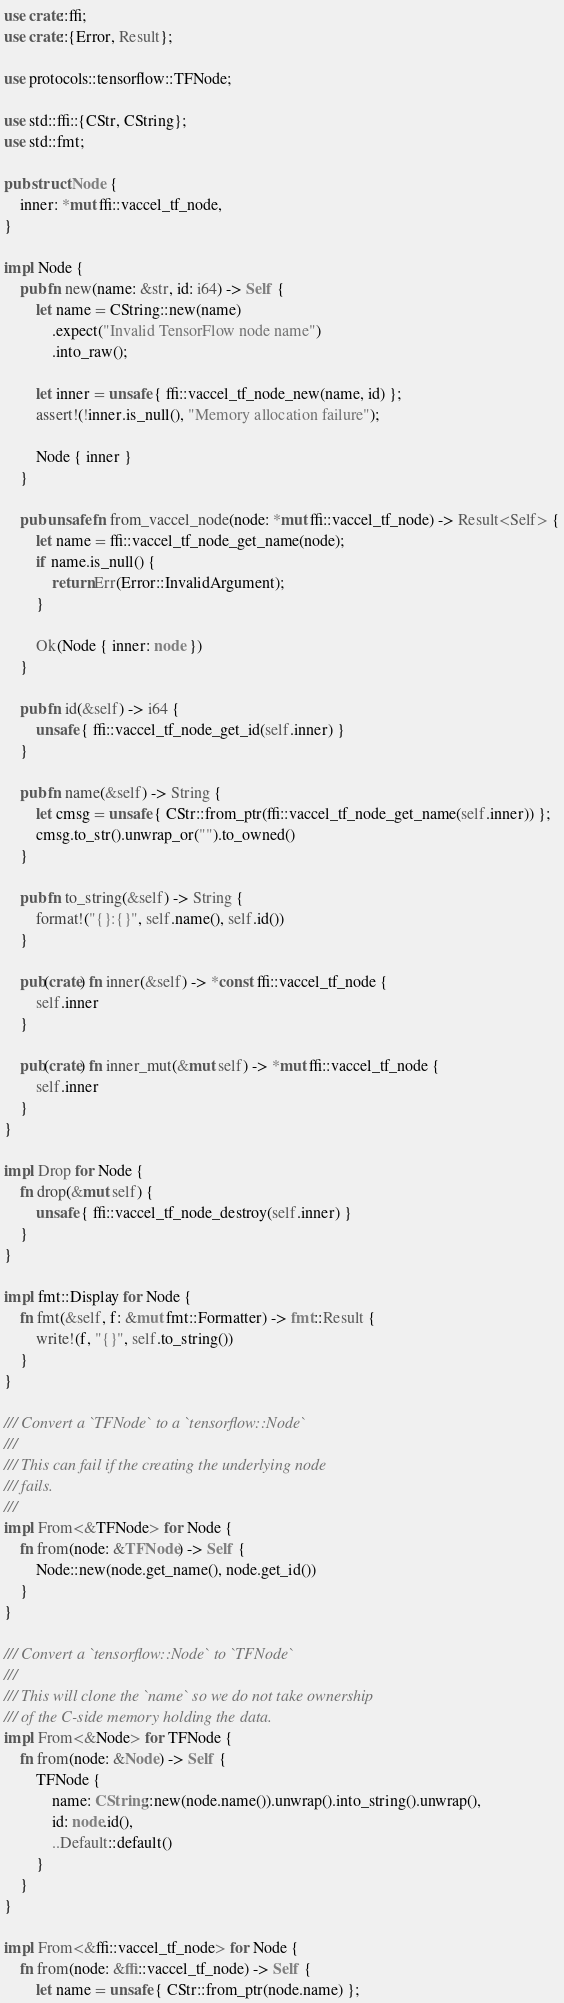<code> <loc_0><loc_0><loc_500><loc_500><_Rust_>use crate::ffi;
use crate::{Error, Result};

use protocols::tensorflow::TFNode;

use std::ffi::{CStr, CString};
use std::fmt;

pub struct Node {
    inner: *mut ffi::vaccel_tf_node,
}

impl Node {
    pub fn new(name: &str, id: i64) -> Self {
        let name = CString::new(name)
            .expect("Invalid TensorFlow node name")
            .into_raw();

        let inner = unsafe { ffi::vaccel_tf_node_new(name, id) };
        assert!(!inner.is_null(), "Memory allocation failure");

        Node { inner }
    }

    pub unsafe fn from_vaccel_node(node: *mut ffi::vaccel_tf_node) -> Result<Self> {
        let name = ffi::vaccel_tf_node_get_name(node);
        if name.is_null() {
            return Err(Error::InvalidArgument);
        }

        Ok(Node { inner: node })
    }

    pub fn id(&self) -> i64 {
        unsafe { ffi::vaccel_tf_node_get_id(self.inner) }
    }

    pub fn name(&self) -> String {
        let cmsg = unsafe { CStr::from_ptr(ffi::vaccel_tf_node_get_name(self.inner)) };
        cmsg.to_str().unwrap_or("").to_owned()
    }

    pub fn to_string(&self) -> String {
        format!("{}:{}", self.name(), self.id())
    }

    pub(crate) fn inner(&self) -> *const ffi::vaccel_tf_node {
        self.inner
    }

    pub(crate) fn inner_mut(&mut self) -> *mut ffi::vaccel_tf_node {
        self.inner
    }
}

impl Drop for Node {
    fn drop(&mut self) {
        unsafe { ffi::vaccel_tf_node_destroy(self.inner) }
    }
}

impl fmt::Display for Node {
    fn fmt(&self, f: &mut fmt::Formatter) -> fmt::Result {
        write!(f, "{}", self.to_string())
    }
}

/// Convert a `TFNode` to a `tensorflow::Node`
///
/// This can fail if the creating the underlying node
/// fails.
///
impl From<&TFNode> for Node {
    fn from(node: &TFNode) -> Self {
        Node::new(node.get_name(), node.get_id())
    }
}

/// Convert a `tensorflow::Node` to `TFNode`
///
/// This will clone the `name` so we do not take ownership
/// of the C-side memory holding the data.
impl From<&Node> for TFNode {
    fn from(node: &Node) -> Self {
        TFNode {
            name: CString::new(node.name()).unwrap().into_string().unwrap(),
            id: node.id(),
            ..Default::default()
        }
    }
}

impl From<&ffi::vaccel_tf_node> for Node {
    fn from(node: &ffi::vaccel_tf_node) -> Self {
        let name = unsafe { CStr::from_ptr(node.name) };
</code> 